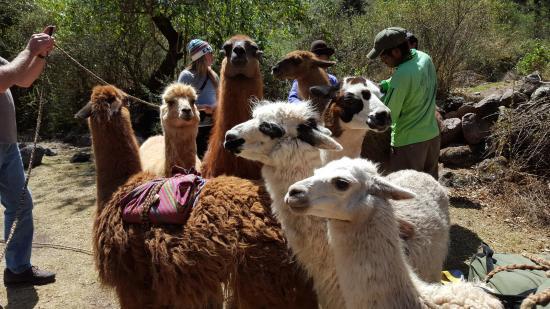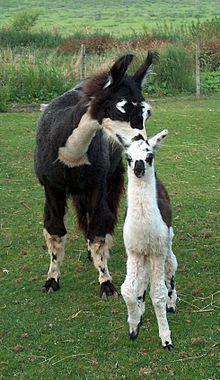The first image is the image on the left, the second image is the image on the right. Given the left and right images, does the statement "In at least one image there is a single baby alpaca with its body facing forward." hold true? Answer yes or no. Yes. The first image is the image on the left, the second image is the image on the right. Analyze the images presented: Is the assertion "The left image shows a man in shorts and sunglasses standing by a white llama wearing a pack, and the right image shows a forward-turned llama wearing some type of attire." valid? Answer yes or no. No. 